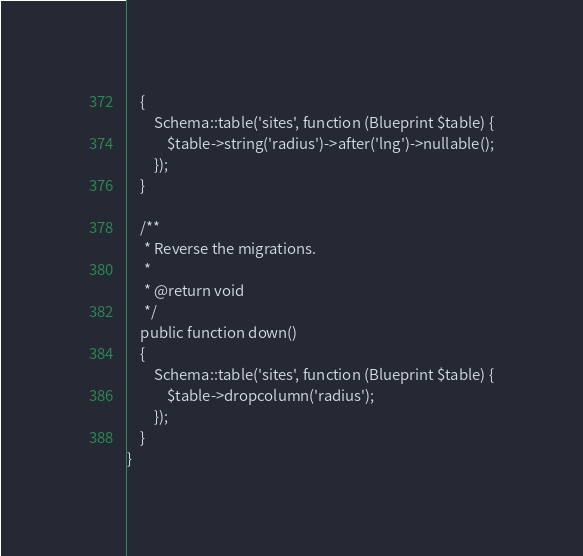<code> <loc_0><loc_0><loc_500><loc_500><_PHP_>    {
        Schema::table('sites', function (Blueprint $table) {
            $table->string('radius')->after('lng')->nullable();
        });
    }

    /**
     * Reverse the migrations.
     *
     * @return void
     */
    public function down()
    {
        Schema::table('sites', function (Blueprint $table) {
            $table->dropcolumn('radius');
        });
    }
}
</code> 